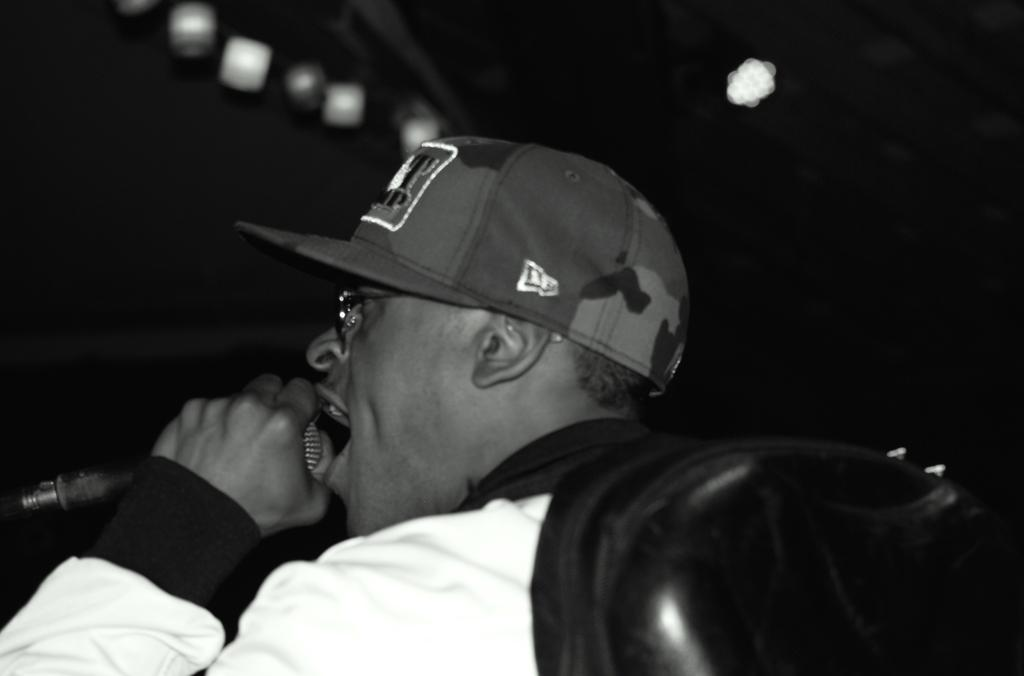What is the man in the image doing? The man is singing. What is the man holding in his hand? The man is holding a microphone in his hand. Can you describe the man's attire in the image? The man is wearing a cap and spectacles. What can be seen in the background of the image? The background of the image is dark. What else is visible in the image besides the man? There are lights visible in the image. Where is the cushion placed in the image? There is no cushion present in the image. What type of bun is the man eating while singing? There is no bun present in the image; the man is holding a microphone and singing. 